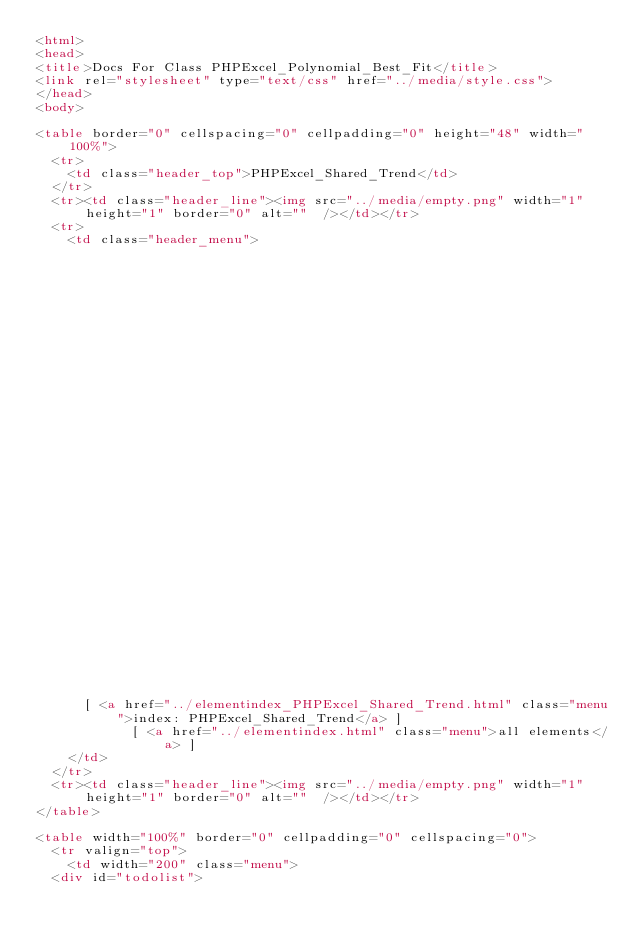<code> <loc_0><loc_0><loc_500><loc_500><_HTML_><html>
<head>
<title>Docs For Class PHPExcel_Polynomial_Best_Fit</title>
<link rel="stylesheet" type="text/css" href="../media/style.css">
</head>
<body>

<table border="0" cellspacing="0" cellpadding="0" height="48" width="100%">
  <tr>
    <td class="header_top">PHPExcel_Shared_Trend</td>
  </tr>
  <tr><td class="header_line"><img src="../media/empty.png" width="1" height="1" border="0" alt=""  /></td></tr>
  <tr>
    <td class="header_menu">
        
                                                                                                                                                                                                                                                                                                                                                                                        
                                                                                                                                                                          		  [ <a href="../classtrees_PHPExcel_Shared_Trend.html" class="menu">class tree: PHPExcel_Shared_Trend</a> ]
		  [ <a href="../elementindex_PHPExcel_Shared_Trend.html" class="menu">index: PHPExcel_Shared_Trend</a> ]
		  	    [ <a href="../elementindex.html" class="menu">all elements</a> ]
    </td>
  </tr>
  <tr><td class="header_line"><img src="../media/empty.png" width="1" height="1" border="0" alt=""  /></td></tr>
</table>

<table width="100%" border="0" cellpadding="0" cellspacing="0">
  <tr valign="top">
    <td width="200" class="menu">
	<div id="todolist"></code> 